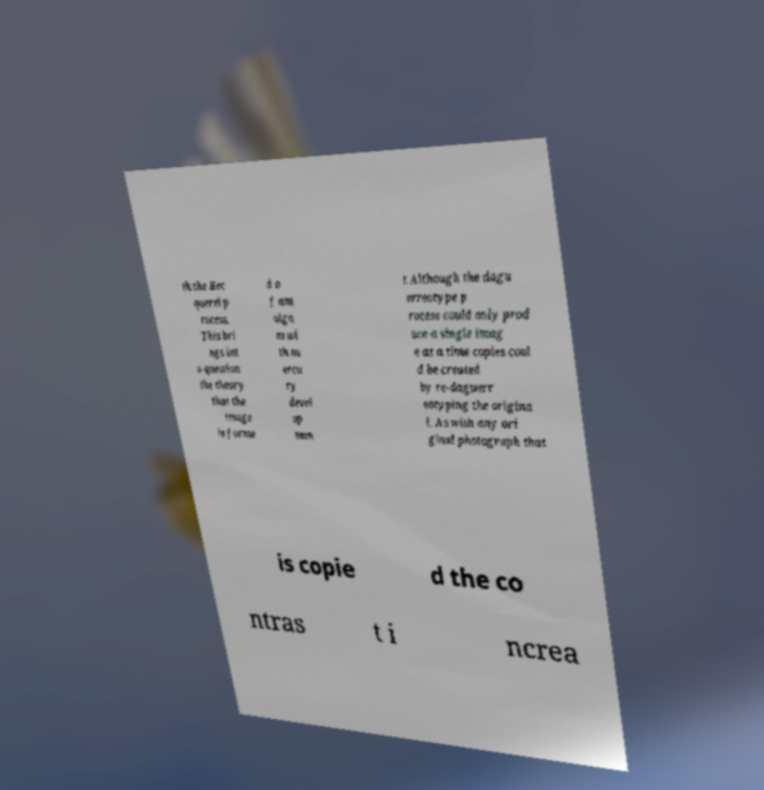There's text embedded in this image that I need extracted. Can you transcribe it verbatim? th the Bec querel p rocess. This bri ngs int o question the theory that the image is forme d o f am alga m wi th m ercu ry devel op men t.Although the dagu erreotype p rocess could only prod uce a single imag e at a time copies coul d be created by re-daguerr eotyping the origina l. As with any ori ginal photograph that is copie d the co ntras t i ncrea 